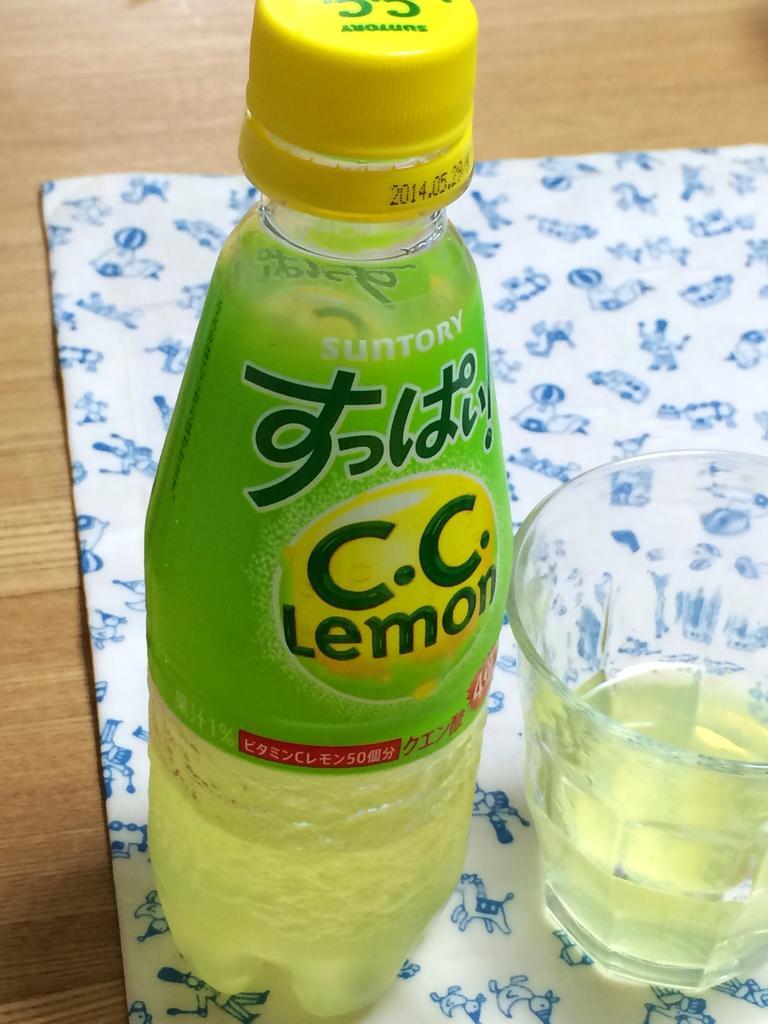Describe this image in one or two sentences. This is a wooden table where a cloth, a lemon bottle and a glass are kept on it. 